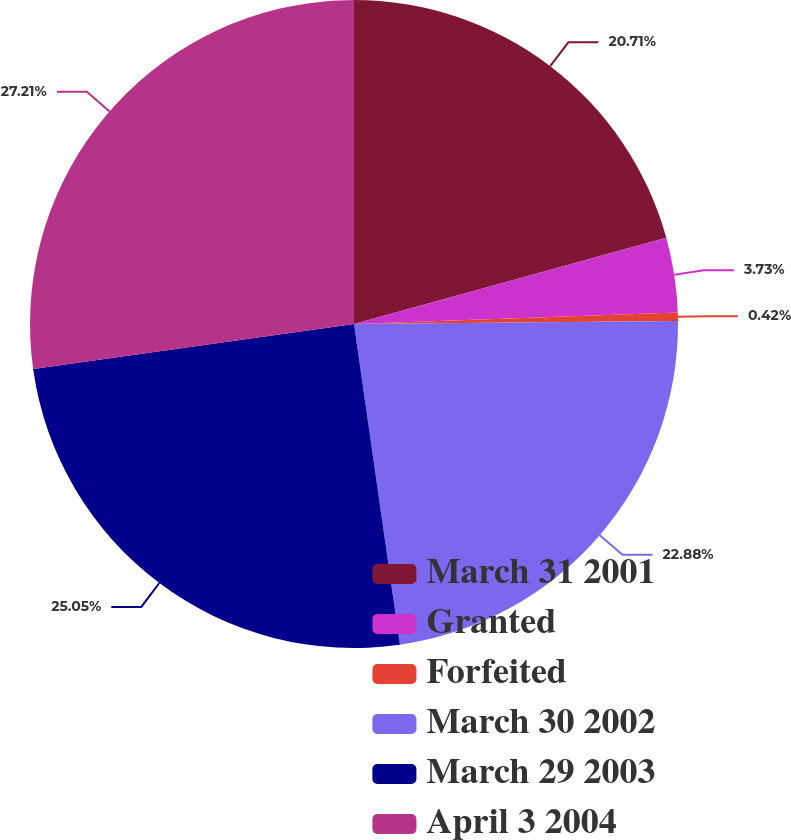Convert chart. <chart><loc_0><loc_0><loc_500><loc_500><pie_chart><fcel>March 31 2001<fcel>Granted<fcel>Forfeited<fcel>March 30 2002<fcel>March 29 2003<fcel>April 3 2004<nl><fcel>20.71%<fcel>3.73%<fcel>0.42%<fcel>22.88%<fcel>25.05%<fcel>27.22%<nl></chart> 